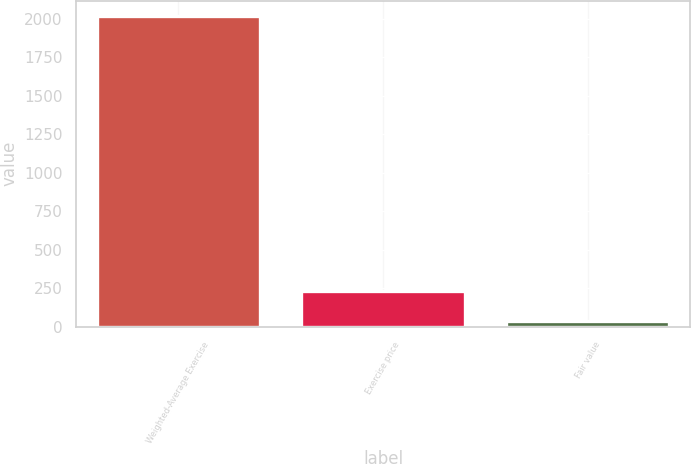Convert chart to OTSL. <chart><loc_0><loc_0><loc_500><loc_500><bar_chart><fcel>Weighted-Average Exercise<fcel>Exercise price<fcel>Fair value<nl><fcel>2016<fcel>235.3<fcel>37.44<nl></chart> 